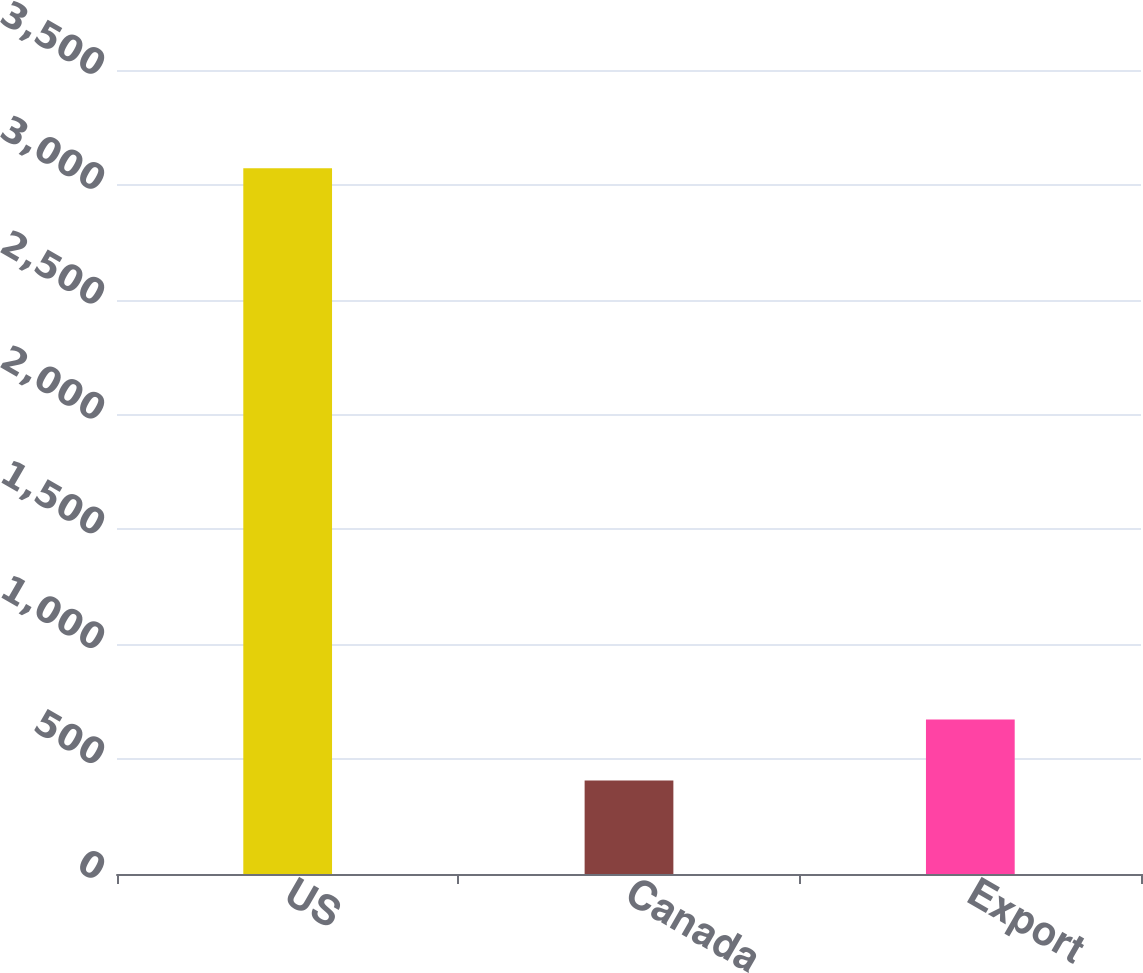<chart> <loc_0><loc_0><loc_500><loc_500><bar_chart><fcel>US<fcel>Canada<fcel>Export<nl><fcel>3072.3<fcel>406.5<fcel>673.08<nl></chart> 